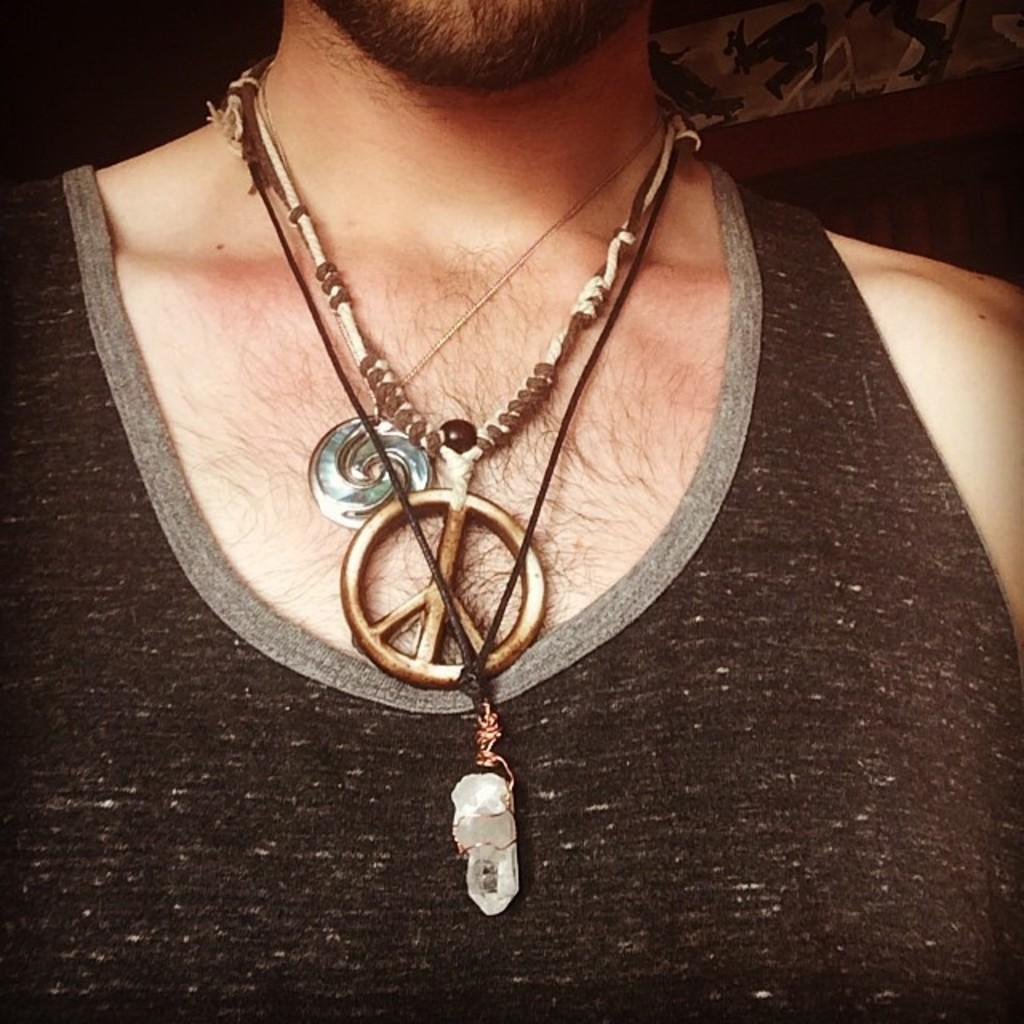Who is the main subject in the image? There is a man in the image. What is the man wearing in the image? The man is wearing black inner wear. What type of memory is the man using to solve a complex mathematical problem in the image? There is no indication in the image that the man is solving a complex mathematical problem or using any type of memory. 